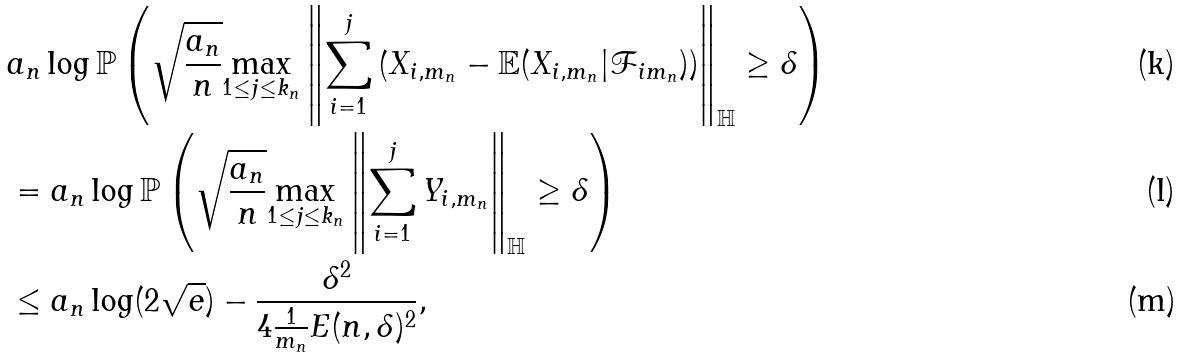Convert formula to latex. <formula><loc_0><loc_0><loc_500><loc_500>& a _ { n } \log \mathbb { P } \left ( \sqrt { \frac { a _ { n } } { n } } \underset { 1 \leq j \leq k _ { n } } { \max } \left \| \sum _ { i = 1 } ^ { j } \left ( X _ { i , m _ { n } } - \mathbb { E } ( X _ { i , m _ { n } } | \mathcal { F } _ { i m _ { n } } ) \right ) \right \| _ { \mathbb { H } } \geq \delta \right ) & \\ & = a _ { n } \log \mathbb { P } \left ( \sqrt { \frac { a _ { n } } { n } } \underset { 1 \leq j \leq k _ { n } } { \max } \left \| \sum _ { i = 1 } ^ { j } Y _ { i , m _ { n } } \right \| _ { \mathbb { H } } \geq \delta \right ) & \\ & \leq a _ { n } \log ( 2 \sqrt { e } ) - \frac { \delta ^ { 2 } } { 4 \frac { 1 } { m _ { n } } E ( n , \delta ) ^ { 2 } } , &</formula> 